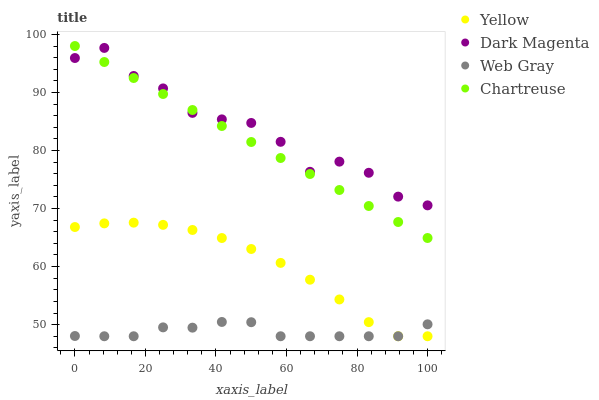Does Web Gray have the minimum area under the curve?
Answer yes or no. Yes. Does Dark Magenta have the maximum area under the curve?
Answer yes or no. Yes. Does Dark Magenta have the minimum area under the curve?
Answer yes or no. No. Does Web Gray have the maximum area under the curve?
Answer yes or no. No. Is Chartreuse the smoothest?
Answer yes or no. Yes. Is Dark Magenta the roughest?
Answer yes or no. Yes. Is Web Gray the smoothest?
Answer yes or no. No. Is Web Gray the roughest?
Answer yes or no. No. Does Web Gray have the lowest value?
Answer yes or no. Yes. Does Dark Magenta have the lowest value?
Answer yes or no. No. Does Chartreuse have the highest value?
Answer yes or no. Yes. Does Dark Magenta have the highest value?
Answer yes or no. No. Is Web Gray less than Dark Magenta?
Answer yes or no. Yes. Is Chartreuse greater than Yellow?
Answer yes or no. Yes. Does Web Gray intersect Yellow?
Answer yes or no. Yes. Is Web Gray less than Yellow?
Answer yes or no. No. Is Web Gray greater than Yellow?
Answer yes or no. No. Does Web Gray intersect Dark Magenta?
Answer yes or no. No. 